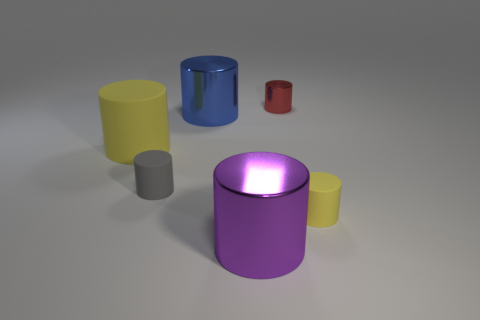How many other objects are the same shape as the small yellow matte thing?
Provide a short and direct response. 5. What shape is the object that is both left of the blue cylinder and behind the tiny gray matte object?
Offer a terse response. Cylinder. Are there any yellow things in front of the tiny shiny thing?
Ensure brevity in your answer.  Yes. What size is the blue thing that is the same shape as the gray matte thing?
Offer a very short reply. Large. Is there anything else that has the same size as the blue shiny cylinder?
Your response must be concise. Yes. Do the blue metallic object and the tiny gray thing have the same shape?
Your response must be concise. Yes. There is a yellow rubber object that is to the left of the tiny rubber cylinder to the right of the tiny red metal thing; how big is it?
Offer a very short reply. Large. There is a large matte object that is the same shape as the blue metal thing; what is its color?
Keep it short and to the point. Yellow. What number of big things are the same color as the tiny metal thing?
Give a very brief answer. 0. How big is the blue metal thing?
Your answer should be very brief. Large. 